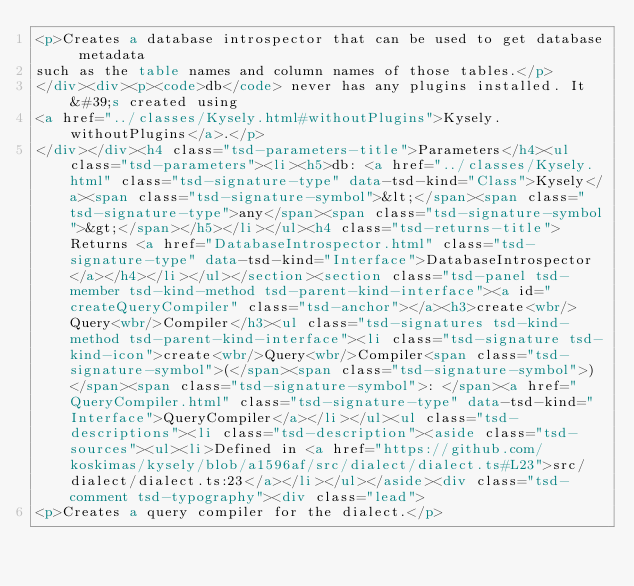<code> <loc_0><loc_0><loc_500><loc_500><_HTML_><p>Creates a database introspector that can be used to get database metadata
such as the table names and column names of those tables.</p>
</div><div><p><code>db</code> never has any plugins installed. It&#39;s created using
<a href="../classes/Kysely.html#withoutPlugins">Kysely.withoutPlugins</a>.</p>
</div></div><h4 class="tsd-parameters-title">Parameters</h4><ul class="tsd-parameters"><li><h5>db: <a href="../classes/Kysely.html" class="tsd-signature-type" data-tsd-kind="Class">Kysely</a><span class="tsd-signature-symbol">&lt;</span><span class="tsd-signature-type">any</span><span class="tsd-signature-symbol">&gt;</span></h5></li></ul><h4 class="tsd-returns-title">Returns <a href="DatabaseIntrospector.html" class="tsd-signature-type" data-tsd-kind="Interface">DatabaseIntrospector</a></h4></li></ul></section><section class="tsd-panel tsd-member tsd-kind-method tsd-parent-kind-interface"><a id="createQueryCompiler" class="tsd-anchor"></a><h3>create<wbr/>Query<wbr/>Compiler</h3><ul class="tsd-signatures tsd-kind-method tsd-parent-kind-interface"><li class="tsd-signature tsd-kind-icon">create<wbr/>Query<wbr/>Compiler<span class="tsd-signature-symbol">(</span><span class="tsd-signature-symbol">)</span><span class="tsd-signature-symbol">: </span><a href="QueryCompiler.html" class="tsd-signature-type" data-tsd-kind="Interface">QueryCompiler</a></li></ul><ul class="tsd-descriptions"><li class="tsd-description"><aside class="tsd-sources"><ul><li>Defined in <a href="https://github.com/koskimas/kysely/blob/a1596af/src/dialect/dialect.ts#L23">src/dialect/dialect.ts:23</a></li></ul></aside><div class="tsd-comment tsd-typography"><div class="lead">
<p>Creates a query compiler for the dialect.</p></code> 